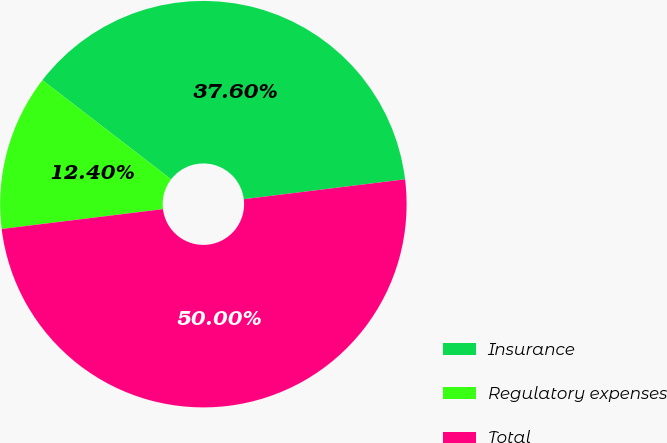Convert chart to OTSL. <chart><loc_0><loc_0><loc_500><loc_500><pie_chart><fcel>Insurance<fcel>Regulatory expenses<fcel>Total<nl><fcel>37.6%<fcel>12.4%<fcel>50.0%<nl></chart> 